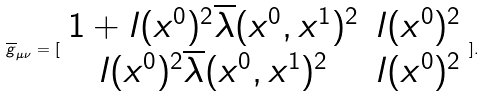Convert formula to latex. <formula><loc_0><loc_0><loc_500><loc_500>\overline { g } _ { \mu \nu } = [ \begin{array} { c c } 1 + l ( x ^ { 0 } ) ^ { 2 } \overline { \lambda } ( x ^ { 0 } , x ^ { 1 } ) ^ { 2 } & l ( x ^ { 0 } ) ^ { 2 } \\ l ( x ^ { 0 } ) ^ { 2 } \overline { \lambda } ( x ^ { 0 } , x ^ { 1 } ) ^ { 2 } & l ( x ^ { 0 } ) ^ { 2 } \end{array} ] .</formula> 